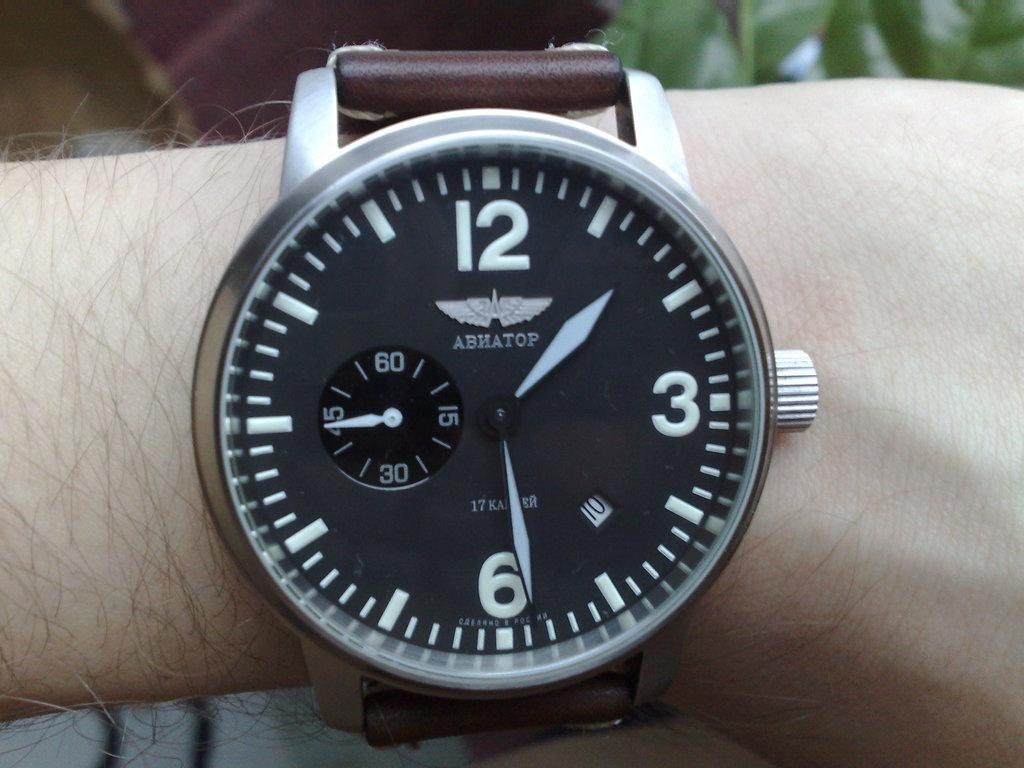<image>
Relay a brief, clear account of the picture shown. A man is wearing an Abhatop brand wrist watch. 